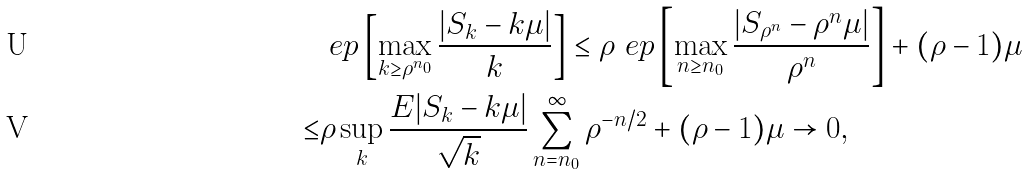Convert formula to latex. <formula><loc_0><loc_0><loc_500><loc_500>& \ e p \left [ \max _ { k \geq \rho ^ { n _ { 0 } } } \frac { | S _ { k } - k \mu | } { k } \right ] \leq \rho \ e p \left [ \max _ { n \geq n _ { 0 } } \frac { | S _ { \rho ^ { n } } - \rho ^ { n } \mu | } { \rho ^ { n } } \right ] + ( \rho - 1 ) \mu \\ \leq & \rho \sup _ { k } \frac { E | S _ { k } - k \mu | } { \sqrt { k } } \sum _ { n = n _ { 0 } } ^ { \infty } \rho ^ { - n / 2 } + ( \rho - 1 ) \mu \to 0 ,</formula> 